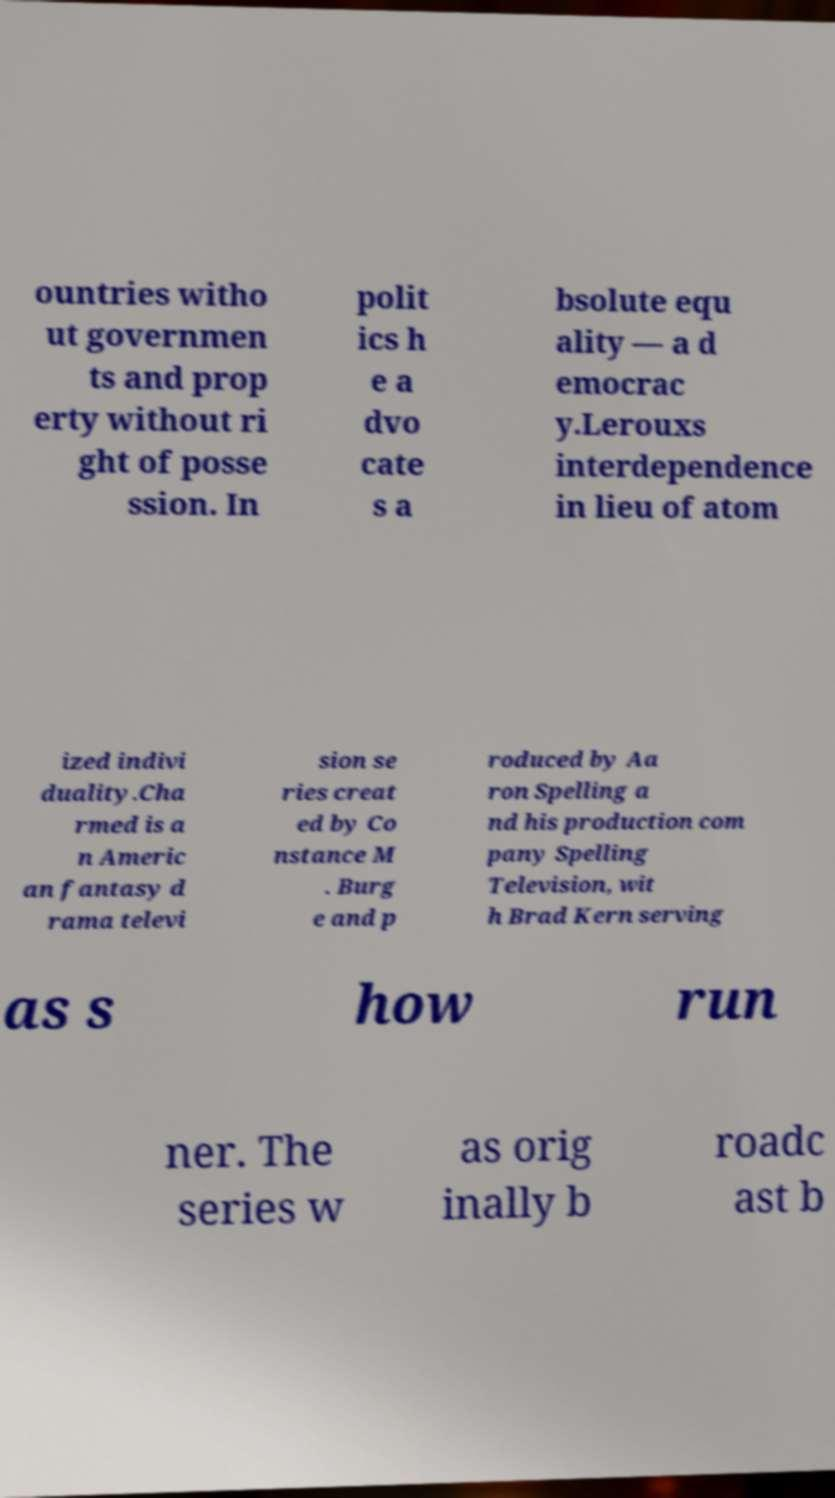There's text embedded in this image that I need extracted. Can you transcribe it verbatim? ountries witho ut governmen ts and prop erty without ri ght of posse ssion. In polit ics h e a dvo cate s a bsolute equ ality — a d emocrac y.Lerouxs interdependence in lieu of atom ized indivi duality.Cha rmed is a n Americ an fantasy d rama televi sion se ries creat ed by Co nstance M . Burg e and p roduced by Aa ron Spelling a nd his production com pany Spelling Television, wit h Brad Kern serving as s how run ner. The series w as orig inally b roadc ast b 